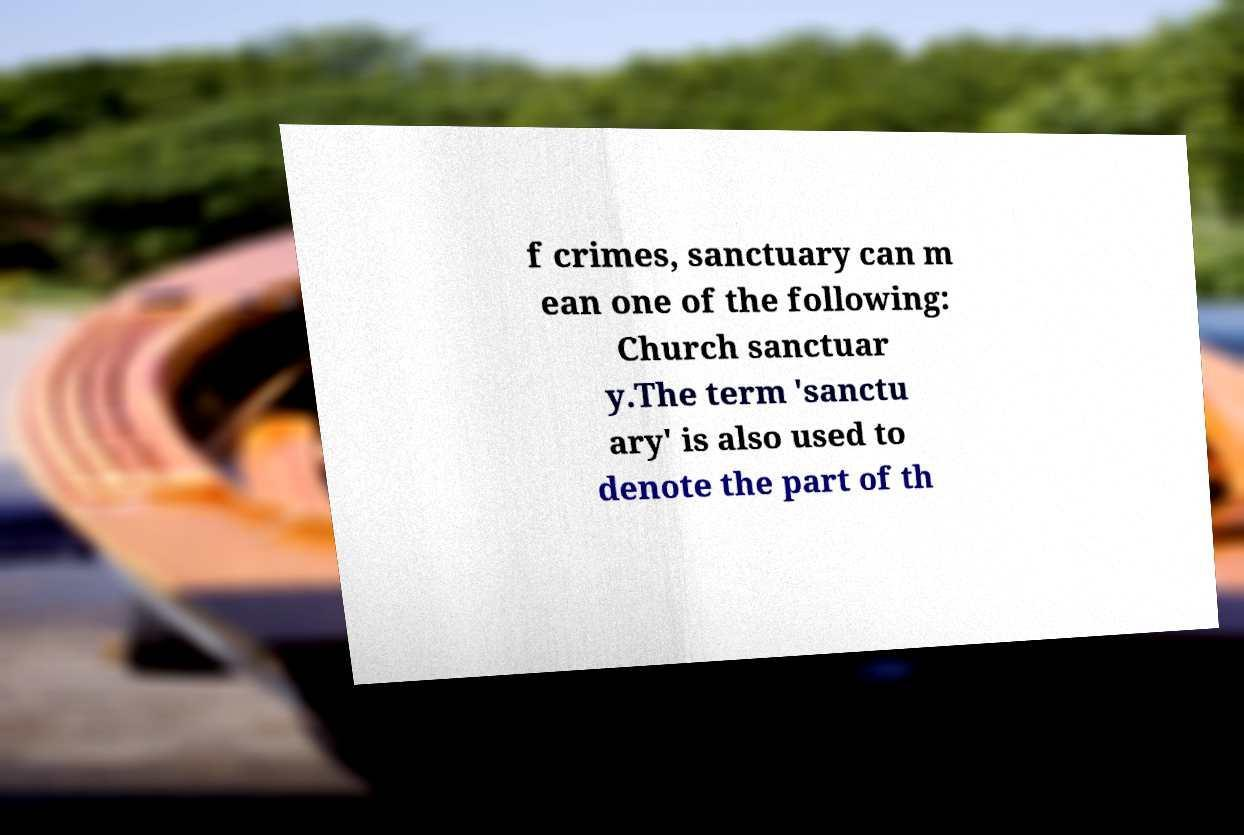There's text embedded in this image that I need extracted. Can you transcribe it verbatim? f crimes, sanctuary can m ean one of the following: Church sanctuar y.The term 'sanctu ary' is also used to denote the part of th 